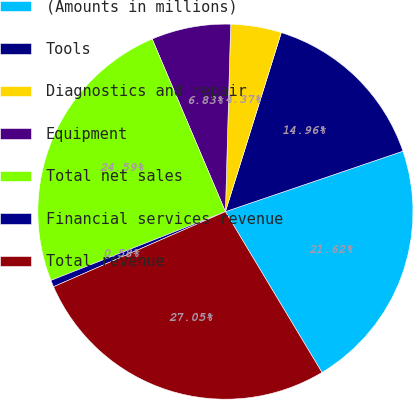<chart> <loc_0><loc_0><loc_500><loc_500><pie_chart><fcel>(Amounts in millions)<fcel>Tools<fcel>Diagnostics and repair<fcel>Equipment<fcel>Total net sales<fcel>Financial services revenue<fcel>Total revenue<nl><fcel>21.62%<fcel>14.96%<fcel>4.37%<fcel>6.83%<fcel>24.59%<fcel>0.58%<fcel>27.05%<nl></chart> 